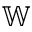Convert formula to latex. <formula><loc_0><loc_0><loc_500><loc_500>{ \mathbb { W } }</formula> 